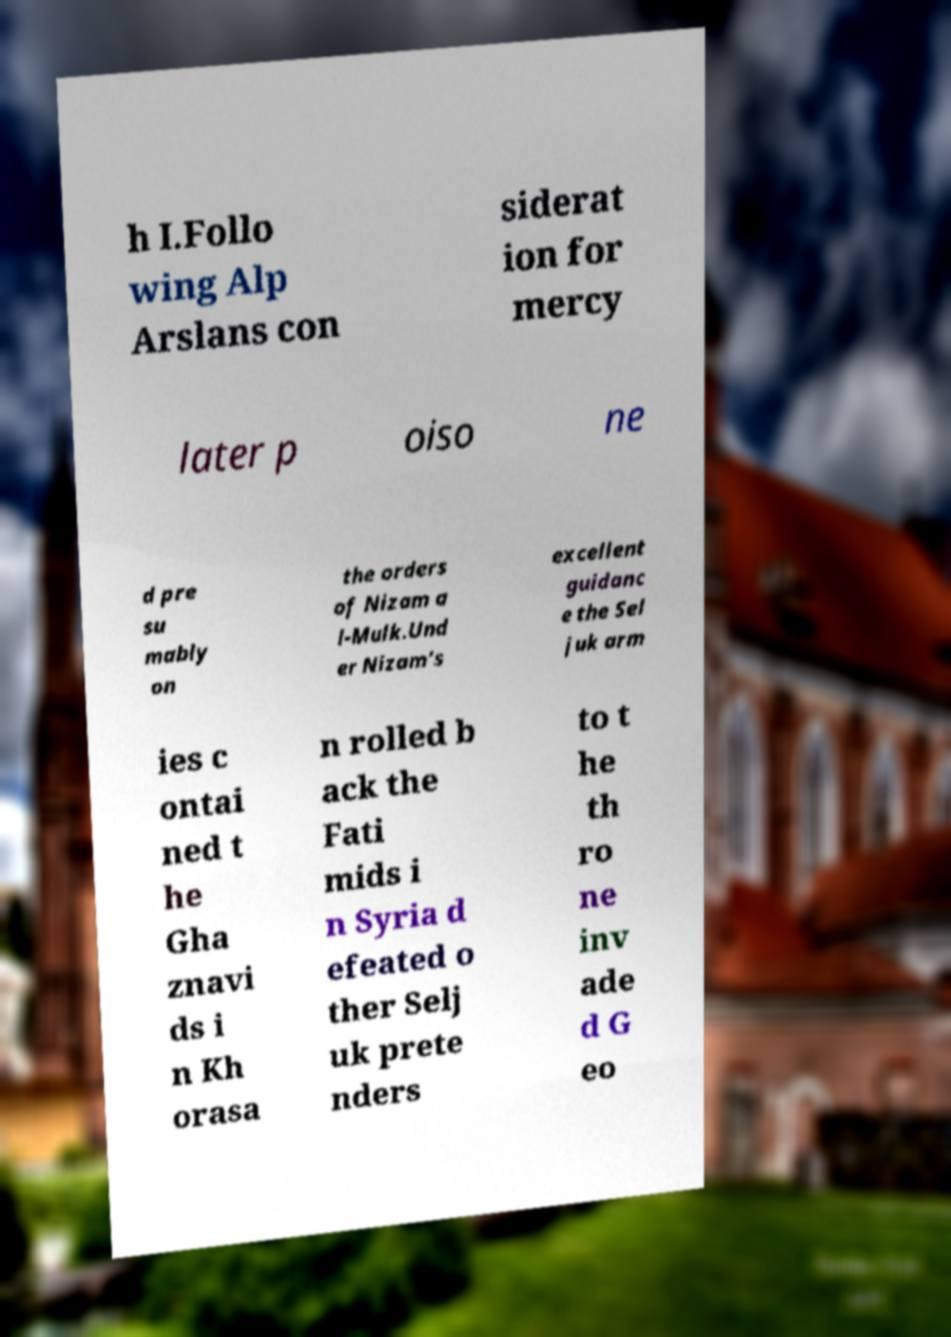Could you extract and type out the text from this image? h I.Follo wing Alp Arslans con siderat ion for mercy later p oiso ne d pre su mably on the orders of Nizam a l-Mulk.Und er Nizam's excellent guidanc e the Sel juk arm ies c ontai ned t he Gha znavi ds i n Kh orasa n rolled b ack the Fati mids i n Syria d efeated o ther Selj uk prete nders to t he th ro ne inv ade d G eo 